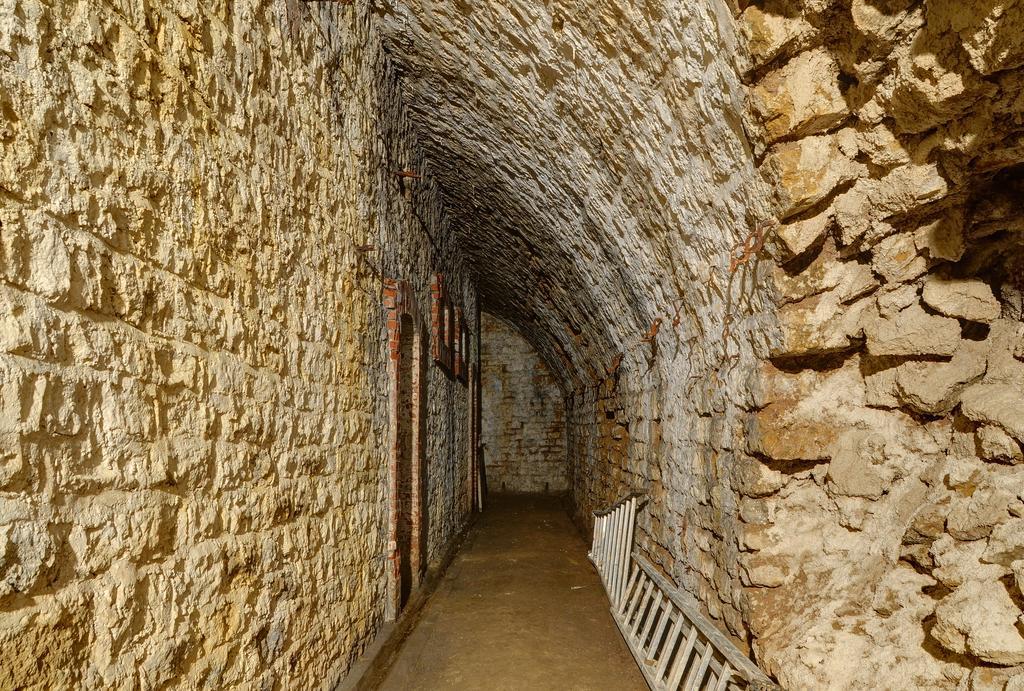How would you summarize this image in a sentence or two? Here we can see wall and on the ground there are two ladders leaning on the wall. On the right we can see collapsed wall and there are stones. 